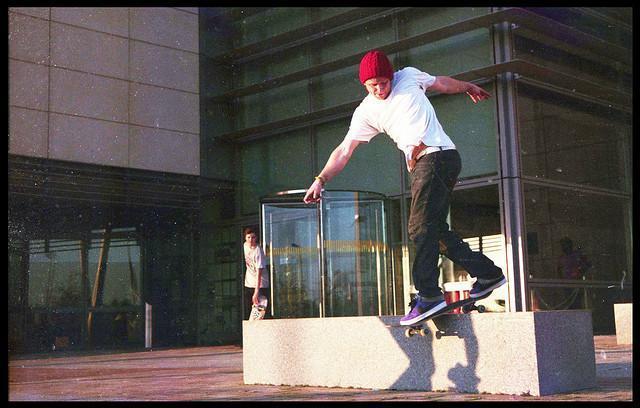How many towers have clocks on them?
Give a very brief answer. 0. 